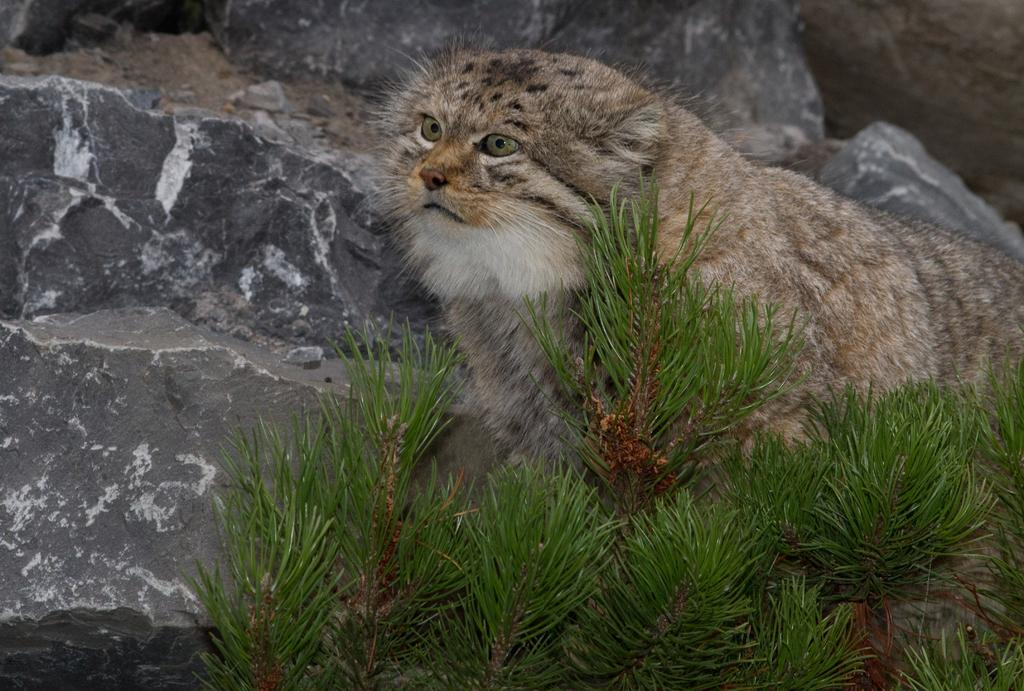What is the main subject in the center of the image? There is an animal in the center of the image. Can you describe the position of the animal in the image? The animal is on the ground. What can be seen in the background of the image? There are rocks visible in the background of the image. What type of bike is being ridden by the animal in the image? There is no bike present in the image; the animal is on the ground. What type of flesh can be seen on the animal in the image? The image does not show any flesh, as it is a photograph of the animal as a whole. 